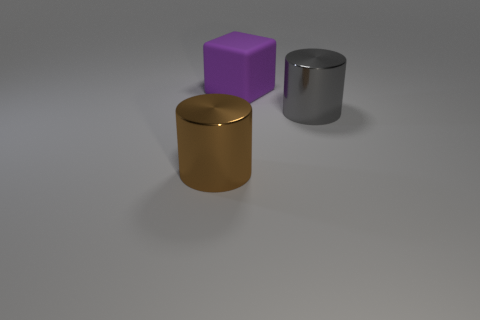Are there any other things that have the same material as the large purple block?
Provide a succinct answer. No. What is the shape of the large metal thing behind the cylinder left of the big cylinder that is on the right side of the big brown shiny cylinder?
Offer a terse response. Cylinder. Is the size of the brown metallic cylinder the same as the metallic object that is on the right side of the big matte cube?
Your answer should be compact. Yes. Is there a brown metal cylinder of the same size as the cube?
Keep it short and to the point. Yes. What number of other things are there of the same material as the brown cylinder
Provide a short and direct response. 1. What color is the big thing that is both in front of the rubber thing and on the left side of the big gray cylinder?
Provide a succinct answer. Brown. Is the big cylinder that is in front of the big gray metallic cylinder made of the same material as the big thing behind the gray metallic thing?
Your response must be concise. No. Do the thing to the left of the cube and the big gray metallic cylinder have the same size?
Your response must be concise. Yes. Do the matte thing and the big object in front of the gray cylinder have the same color?
Provide a succinct answer. No. The big gray metallic object is what shape?
Keep it short and to the point. Cylinder. 